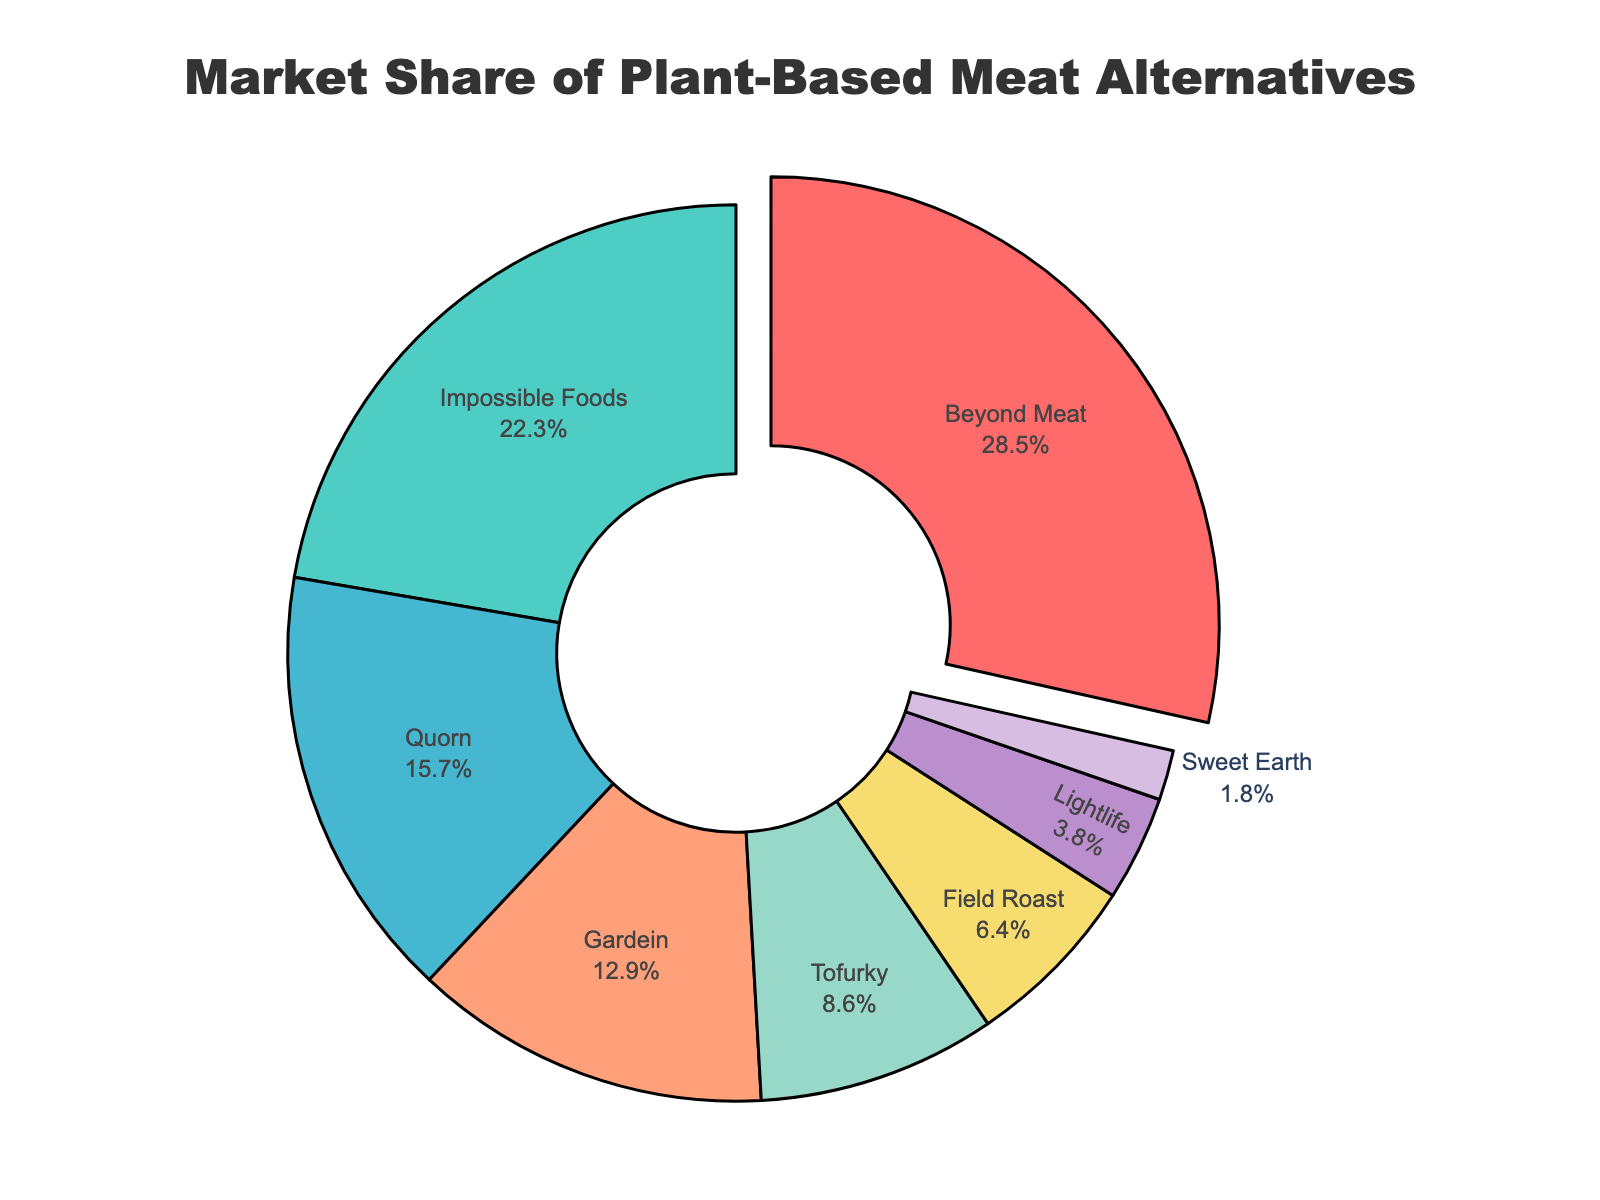What percentage of the market share do Beyond Meat and Impossible Foods together hold? To find the combined market share of Beyond Meat and Impossible Foods, add their individual market shares: 28.5% (Beyond Meat) + 22.3% (Impossible Foods) = 50.8%
Answer: 50.8% Which product has the smallest market share? Identify the product with the smallest slice in the pie chart. Sweet Earth has the smallest market share at 1.8%
Answer: Sweet Earth How much larger is Beyond Meat's market share compared to Tofurky's market share? Subtract Tofurky's market share from Beyond Meat's market share: 28.5% (Beyond Meat) - 8.6% (Tofurky) = 19.9%
Answer: 19.9% Rank the products from highest to lowest market share. List the products in descending order based on their market share: Beyond Meat (28.5%), Impossible Foods (22.3%), Quorn (15.7%), Gardein (12.9%), Tofurky (8.6%), Field Roast (6.4%), Lightlife (3.8%), Sweet Earth (1.8%)
Answer: Beyond Meat, Impossible Foods, Quorn, Gardein, Tofurky, Field Roast, Lightlife, Sweet Earth What is the combined market share of the products with less than 10% market share each? Sum the market shares of Tofurky (8.6%), Field Roast (6.4%), Lightlife (3.8%), and Sweet Earth (1.8%): 8.6% + 6.4% + 3.8% + 1.8% = 20.6%
Answer: 20.6% What color represents Gardein? Look at the slice labeled “Gardein” and identify its color, which is a sort of orange shade
Answer: orange By how many percentage points does Beyond Meat lead Impossible Foods? Subtract Impossible Foods' market share from Beyond Meat's market share: 28.5% (Beyond Meat) - 22.3% (Impossible Foods) = 6.2 percentage points
Answer: 6.2 How much market share do the top three products hold together? Sum the market shares of Beyond Meat, Impossible Foods, and Quorn: 28.5% + 22.3% + 15.7% = 66.5%
Answer: 66.5% 